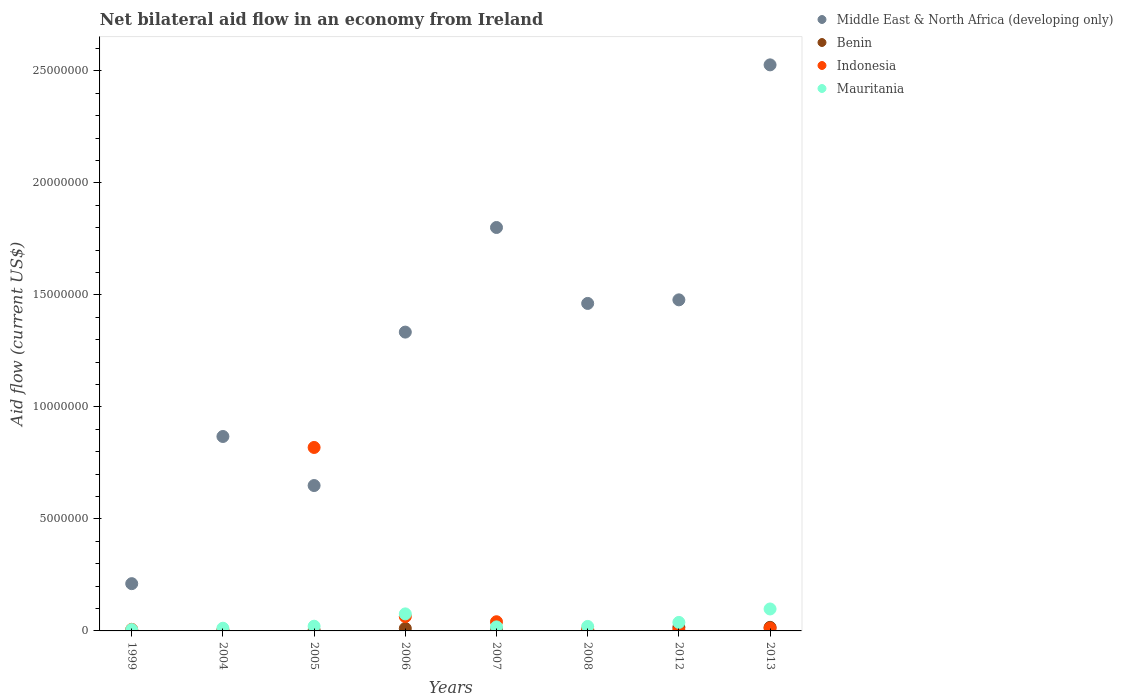What is the net bilateral aid flow in Mauritania in 2005?
Provide a short and direct response. 2.10e+05. Across all years, what is the maximum net bilateral aid flow in Mauritania?
Offer a terse response. 9.80e+05. Across all years, what is the minimum net bilateral aid flow in Mauritania?
Provide a succinct answer. 6.00e+04. In which year was the net bilateral aid flow in Benin maximum?
Your response must be concise. 2012. What is the total net bilateral aid flow in Middle East & North Africa (developing only) in the graph?
Offer a very short reply. 1.03e+08. What is the difference between the net bilateral aid flow in Indonesia in 2006 and that in 2008?
Provide a short and direct response. 5.60e+05. What is the average net bilateral aid flow in Mauritania per year?
Make the answer very short. 3.61e+05. In the year 1999, what is the difference between the net bilateral aid flow in Benin and net bilateral aid flow in Indonesia?
Provide a short and direct response. -5.00e+04. In how many years, is the net bilateral aid flow in Benin greater than 24000000 US$?
Your answer should be very brief. 0. Is the net bilateral aid flow in Indonesia in 2005 less than that in 2012?
Your response must be concise. No. What is the difference between the highest and the second highest net bilateral aid flow in Indonesia?
Provide a succinct answer. 7.55e+06. What is the difference between the highest and the lowest net bilateral aid flow in Mauritania?
Offer a very short reply. 9.20e+05. In how many years, is the net bilateral aid flow in Middle East & North Africa (developing only) greater than the average net bilateral aid flow in Middle East & North Africa (developing only) taken over all years?
Provide a short and direct response. 5. Is it the case that in every year, the sum of the net bilateral aid flow in Benin and net bilateral aid flow in Mauritania  is greater than the sum of net bilateral aid flow in Middle East & North Africa (developing only) and net bilateral aid flow in Indonesia?
Make the answer very short. No. Is the net bilateral aid flow in Middle East & North Africa (developing only) strictly greater than the net bilateral aid flow in Mauritania over the years?
Offer a very short reply. Yes. Is the net bilateral aid flow in Benin strictly less than the net bilateral aid flow in Indonesia over the years?
Ensure brevity in your answer.  No. How many dotlines are there?
Make the answer very short. 4. Are the values on the major ticks of Y-axis written in scientific E-notation?
Your answer should be compact. No. Does the graph contain grids?
Your answer should be very brief. No. How are the legend labels stacked?
Keep it short and to the point. Vertical. What is the title of the graph?
Your answer should be very brief. Net bilateral aid flow in an economy from Ireland. Does "Nicaragua" appear as one of the legend labels in the graph?
Provide a succinct answer. No. What is the label or title of the X-axis?
Offer a very short reply. Years. What is the Aid flow (current US$) of Middle East & North Africa (developing only) in 1999?
Provide a short and direct response. 2.11e+06. What is the Aid flow (current US$) of Middle East & North Africa (developing only) in 2004?
Give a very brief answer. 8.68e+06. What is the Aid flow (current US$) of Benin in 2004?
Your response must be concise. 10000. What is the Aid flow (current US$) in Indonesia in 2004?
Your response must be concise. 3.00e+04. What is the Aid flow (current US$) of Middle East & North Africa (developing only) in 2005?
Keep it short and to the point. 6.49e+06. What is the Aid flow (current US$) of Indonesia in 2005?
Give a very brief answer. 8.19e+06. What is the Aid flow (current US$) in Middle East & North Africa (developing only) in 2006?
Give a very brief answer. 1.33e+07. What is the Aid flow (current US$) in Benin in 2006?
Your answer should be very brief. 1.10e+05. What is the Aid flow (current US$) in Indonesia in 2006?
Offer a very short reply. 6.40e+05. What is the Aid flow (current US$) in Mauritania in 2006?
Your response must be concise. 7.60e+05. What is the Aid flow (current US$) of Middle East & North Africa (developing only) in 2007?
Ensure brevity in your answer.  1.80e+07. What is the Aid flow (current US$) of Middle East & North Africa (developing only) in 2008?
Offer a very short reply. 1.46e+07. What is the Aid flow (current US$) of Benin in 2008?
Provide a succinct answer. 6.00e+04. What is the Aid flow (current US$) of Mauritania in 2008?
Ensure brevity in your answer.  2.00e+05. What is the Aid flow (current US$) in Middle East & North Africa (developing only) in 2012?
Your answer should be very brief. 1.48e+07. What is the Aid flow (current US$) of Benin in 2012?
Your answer should be compact. 1.60e+05. What is the Aid flow (current US$) in Mauritania in 2012?
Make the answer very short. 3.80e+05. What is the Aid flow (current US$) in Middle East & North Africa (developing only) in 2013?
Your answer should be compact. 2.53e+07. What is the Aid flow (current US$) of Benin in 2013?
Make the answer very short. 1.60e+05. What is the Aid flow (current US$) in Mauritania in 2013?
Provide a short and direct response. 9.80e+05. Across all years, what is the maximum Aid flow (current US$) in Middle East & North Africa (developing only)?
Your answer should be compact. 2.53e+07. Across all years, what is the maximum Aid flow (current US$) of Benin?
Make the answer very short. 1.60e+05. Across all years, what is the maximum Aid flow (current US$) in Indonesia?
Provide a succinct answer. 8.19e+06. Across all years, what is the maximum Aid flow (current US$) in Mauritania?
Offer a terse response. 9.80e+05. Across all years, what is the minimum Aid flow (current US$) of Middle East & North Africa (developing only)?
Make the answer very short. 2.11e+06. Across all years, what is the minimum Aid flow (current US$) in Mauritania?
Keep it short and to the point. 6.00e+04. What is the total Aid flow (current US$) of Middle East & North Africa (developing only) in the graph?
Offer a terse response. 1.03e+08. What is the total Aid flow (current US$) in Benin in the graph?
Keep it short and to the point. 6.40e+05. What is the total Aid flow (current US$) in Indonesia in the graph?
Your response must be concise. 9.57e+06. What is the total Aid flow (current US$) of Mauritania in the graph?
Ensure brevity in your answer.  2.89e+06. What is the difference between the Aid flow (current US$) in Middle East & North Africa (developing only) in 1999 and that in 2004?
Make the answer very short. -6.57e+06. What is the difference between the Aid flow (current US$) of Middle East & North Africa (developing only) in 1999 and that in 2005?
Give a very brief answer. -4.38e+06. What is the difference between the Aid flow (current US$) of Indonesia in 1999 and that in 2005?
Your answer should be compact. -8.12e+06. What is the difference between the Aid flow (current US$) of Mauritania in 1999 and that in 2005?
Your answer should be compact. -1.50e+05. What is the difference between the Aid flow (current US$) of Middle East & North Africa (developing only) in 1999 and that in 2006?
Make the answer very short. -1.12e+07. What is the difference between the Aid flow (current US$) of Indonesia in 1999 and that in 2006?
Ensure brevity in your answer.  -5.70e+05. What is the difference between the Aid flow (current US$) of Mauritania in 1999 and that in 2006?
Your answer should be compact. -7.00e+05. What is the difference between the Aid flow (current US$) in Middle East & North Africa (developing only) in 1999 and that in 2007?
Your answer should be very brief. -1.59e+07. What is the difference between the Aid flow (current US$) of Middle East & North Africa (developing only) in 1999 and that in 2008?
Your response must be concise. -1.25e+07. What is the difference between the Aid flow (current US$) in Benin in 1999 and that in 2008?
Provide a short and direct response. -4.00e+04. What is the difference between the Aid flow (current US$) of Indonesia in 1999 and that in 2008?
Provide a short and direct response. -10000. What is the difference between the Aid flow (current US$) of Mauritania in 1999 and that in 2008?
Provide a short and direct response. -1.40e+05. What is the difference between the Aid flow (current US$) of Middle East & North Africa (developing only) in 1999 and that in 2012?
Your response must be concise. -1.27e+07. What is the difference between the Aid flow (current US$) of Indonesia in 1999 and that in 2012?
Ensure brevity in your answer.  4.00e+04. What is the difference between the Aid flow (current US$) in Mauritania in 1999 and that in 2012?
Give a very brief answer. -3.20e+05. What is the difference between the Aid flow (current US$) of Middle East & North Africa (developing only) in 1999 and that in 2013?
Provide a short and direct response. -2.32e+07. What is the difference between the Aid flow (current US$) in Indonesia in 1999 and that in 2013?
Provide a succinct answer. -5.00e+04. What is the difference between the Aid flow (current US$) in Mauritania in 1999 and that in 2013?
Provide a succinct answer. -9.20e+05. What is the difference between the Aid flow (current US$) of Middle East & North Africa (developing only) in 2004 and that in 2005?
Your answer should be compact. 2.19e+06. What is the difference between the Aid flow (current US$) of Indonesia in 2004 and that in 2005?
Your response must be concise. -8.16e+06. What is the difference between the Aid flow (current US$) of Mauritania in 2004 and that in 2005?
Offer a terse response. -9.00e+04. What is the difference between the Aid flow (current US$) in Middle East & North Africa (developing only) in 2004 and that in 2006?
Your answer should be very brief. -4.66e+06. What is the difference between the Aid flow (current US$) of Indonesia in 2004 and that in 2006?
Provide a succinct answer. -6.10e+05. What is the difference between the Aid flow (current US$) in Mauritania in 2004 and that in 2006?
Your answer should be very brief. -6.40e+05. What is the difference between the Aid flow (current US$) in Middle East & North Africa (developing only) in 2004 and that in 2007?
Offer a very short reply. -9.33e+06. What is the difference between the Aid flow (current US$) in Indonesia in 2004 and that in 2007?
Offer a very short reply. -3.80e+05. What is the difference between the Aid flow (current US$) in Mauritania in 2004 and that in 2007?
Ensure brevity in your answer.  -6.00e+04. What is the difference between the Aid flow (current US$) in Middle East & North Africa (developing only) in 2004 and that in 2008?
Provide a short and direct response. -5.94e+06. What is the difference between the Aid flow (current US$) of Middle East & North Africa (developing only) in 2004 and that in 2012?
Provide a short and direct response. -6.10e+06. What is the difference between the Aid flow (current US$) in Mauritania in 2004 and that in 2012?
Make the answer very short. -2.60e+05. What is the difference between the Aid flow (current US$) of Middle East & North Africa (developing only) in 2004 and that in 2013?
Ensure brevity in your answer.  -1.66e+07. What is the difference between the Aid flow (current US$) of Indonesia in 2004 and that in 2013?
Keep it short and to the point. -9.00e+04. What is the difference between the Aid flow (current US$) of Mauritania in 2004 and that in 2013?
Offer a terse response. -8.60e+05. What is the difference between the Aid flow (current US$) in Middle East & North Africa (developing only) in 2005 and that in 2006?
Ensure brevity in your answer.  -6.85e+06. What is the difference between the Aid flow (current US$) in Benin in 2005 and that in 2006?
Your answer should be very brief. -8.00e+04. What is the difference between the Aid flow (current US$) of Indonesia in 2005 and that in 2006?
Your answer should be very brief. 7.55e+06. What is the difference between the Aid flow (current US$) in Mauritania in 2005 and that in 2006?
Your answer should be very brief. -5.50e+05. What is the difference between the Aid flow (current US$) of Middle East & North Africa (developing only) in 2005 and that in 2007?
Give a very brief answer. -1.15e+07. What is the difference between the Aid flow (current US$) of Benin in 2005 and that in 2007?
Give a very brief answer. -6.00e+04. What is the difference between the Aid flow (current US$) in Indonesia in 2005 and that in 2007?
Keep it short and to the point. 7.78e+06. What is the difference between the Aid flow (current US$) of Middle East & North Africa (developing only) in 2005 and that in 2008?
Offer a terse response. -8.13e+06. What is the difference between the Aid flow (current US$) in Indonesia in 2005 and that in 2008?
Give a very brief answer. 8.11e+06. What is the difference between the Aid flow (current US$) in Mauritania in 2005 and that in 2008?
Keep it short and to the point. 10000. What is the difference between the Aid flow (current US$) of Middle East & North Africa (developing only) in 2005 and that in 2012?
Give a very brief answer. -8.29e+06. What is the difference between the Aid flow (current US$) in Indonesia in 2005 and that in 2012?
Keep it short and to the point. 8.16e+06. What is the difference between the Aid flow (current US$) of Mauritania in 2005 and that in 2012?
Your answer should be compact. -1.70e+05. What is the difference between the Aid flow (current US$) in Middle East & North Africa (developing only) in 2005 and that in 2013?
Keep it short and to the point. -1.88e+07. What is the difference between the Aid flow (current US$) of Benin in 2005 and that in 2013?
Keep it short and to the point. -1.30e+05. What is the difference between the Aid flow (current US$) of Indonesia in 2005 and that in 2013?
Offer a very short reply. 8.07e+06. What is the difference between the Aid flow (current US$) of Mauritania in 2005 and that in 2013?
Provide a short and direct response. -7.70e+05. What is the difference between the Aid flow (current US$) in Middle East & North Africa (developing only) in 2006 and that in 2007?
Keep it short and to the point. -4.67e+06. What is the difference between the Aid flow (current US$) in Mauritania in 2006 and that in 2007?
Your response must be concise. 5.80e+05. What is the difference between the Aid flow (current US$) of Middle East & North Africa (developing only) in 2006 and that in 2008?
Ensure brevity in your answer.  -1.28e+06. What is the difference between the Aid flow (current US$) in Indonesia in 2006 and that in 2008?
Provide a succinct answer. 5.60e+05. What is the difference between the Aid flow (current US$) in Mauritania in 2006 and that in 2008?
Provide a succinct answer. 5.60e+05. What is the difference between the Aid flow (current US$) of Middle East & North Africa (developing only) in 2006 and that in 2012?
Give a very brief answer. -1.44e+06. What is the difference between the Aid flow (current US$) in Indonesia in 2006 and that in 2012?
Offer a terse response. 6.10e+05. What is the difference between the Aid flow (current US$) of Mauritania in 2006 and that in 2012?
Give a very brief answer. 3.80e+05. What is the difference between the Aid flow (current US$) in Middle East & North Africa (developing only) in 2006 and that in 2013?
Offer a very short reply. -1.19e+07. What is the difference between the Aid flow (current US$) in Benin in 2006 and that in 2013?
Offer a very short reply. -5.00e+04. What is the difference between the Aid flow (current US$) in Indonesia in 2006 and that in 2013?
Your answer should be compact. 5.20e+05. What is the difference between the Aid flow (current US$) in Mauritania in 2006 and that in 2013?
Offer a very short reply. -2.20e+05. What is the difference between the Aid flow (current US$) of Middle East & North Africa (developing only) in 2007 and that in 2008?
Your answer should be very brief. 3.39e+06. What is the difference between the Aid flow (current US$) in Benin in 2007 and that in 2008?
Make the answer very short. 3.00e+04. What is the difference between the Aid flow (current US$) in Indonesia in 2007 and that in 2008?
Your answer should be compact. 3.30e+05. What is the difference between the Aid flow (current US$) in Middle East & North Africa (developing only) in 2007 and that in 2012?
Your answer should be compact. 3.23e+06. What is the difference between the Aid flow (current US$) of Indonesia in 2007 and that in 2012?
Give a very brief answer. 3.80e+05. What is the difference between the Aid flow (current US$) in Middle East & North Africa (developing only) in 2007 and that in 2013?
Give a very brief answer. -7.26e+06. What is the difference between the Aid flow (current US$) of Mauritania in 2007 and that in 2013?
Ensure brevity in your answer.  -8.00e+05. What is the difference between the Aid flow (current US$) of Middle East & North Africa (developing only) in 2008 and that in 2012?
Offer a very short reply. -1.60e+05. What is the difference between the Aid flow (current US$) in Benin in 2008 and that in 2012?
Offer a terse response. -1.00e+05. What is the difference between the Aid flow (current US$) of Indonesia in 2008 and that in 2012?
Ensure brevity in your answer.  5.00e+04. What is the difference between the Aid flow (current US$) of Mauritania in 2008 and that in 2012?
Make the answer very short. -1.80e+05. What is the difference between the Aid flow (current US$) in Middle East & North Africa (developing only) in 2008 and that in 2013?
Offer a terse response. -1.06e+07. What is the difference between the Aid flow (current US$) of Benin in 2008 and that in 2013?
Give a very brief answer. -1.00e+05. What is the difference between the Aid flow (current US$) of Indonesia in 2008 and that in 2013?
Provide a short and direct response. -4.00e+04. What is the difference between the Aid flow (current US$) of Mauritania in 2008 and that in 2013?
Your answer should be very brief. -7.80e+05. What is the difference between the Aid flow (current US$) in Middle East & North Africa (developing only) in 2012 and that in 2013?
Offer a very short reply. -1.05e+07. What is the difference between the Aid flow (current US$) in Mauritania in 2012 and that in 2013?
Your answer should be very brief. -6.00e+05. What is the difference between the Aid flow (current US$) in Middle East & North Africa (developing only) in 1999 and the Aid flow (current US$) in Benin in 2004?
Your answer should be very brief. 2.10e+06. What is the difference between the Aid flow (current US$) of Middle East & North Africa (developing only) in 1999 and the Aid flow (current US$) of Indonesia in 2004?
Provide a short and direct response. 2.08e+06. What is the difference between the Aid flow (current US$) of Middle East & North Africa (developing only) in 1999 and the Aid flow (current US$) of Mauritania in 2004?
Provide a succinct answer. 1.99e+06. What is the difference between the Aid flow (current US$) of Indonesia in 1999 and the Aid flow (current US$) of Mauritania in 2004?
Your answer should be very brief. -5.00e+04. What is the difference between the Aid flow (current US$) of Middle East & North Africa (developing only) in 1999 and the Aid flow (current US$) of Benin in 2005?
Give a very brief answer. 2.08e+06. What is the difference between the Aid flow (current US$) in Middle East & North Africa (developing only) in 1999 and the Aid flow (current US$) in Indonesia in 2005?
Your answer should be compact. -6.08e+06. What is the difference between the Aid flow (current US$) of Middle East & North Africa (developing only) in 1999 and the Aid flow (current US$) of Mauritania in 2005?
Provide a succinct answer. 1.90e+06. What is the difference between the Aid flow (current US$) in Benin in 1999 and the Aid flow (current US$) in Indonesia in 2005?
Your response must be concise. -8.17e+06. What is the difference between the Aid flow (current US$) in Indonesia in 1999 and the Aid flow (current US$) in Mauritania in 2005?
Ensure brevity in your answer.  -1.40e+05. What is the difference between the Aid flow (current US$) of Middle East & North Africa (developing only) in 1999 and the Aid flow (current US$) of Indonesia in 2006?
Provide a short and direct response. 1.47e+06. What is the difference between the Aid flow (current US$) of Middle East & North Africa (developing only) in 1999 and the Aid flow (current US$) of Mauritania in 2006?
Give a very brief answer. 1.35e+06. What is the difference between the Aid flow (current US$) in Benin in 1999 and the Aid flow (current US$) in Indonesia in 2006?
Offer a very short reply. -6.20e+05. What is the difference between the Aid flow (current US$) of Benin in 1999 and the Aid flow (current US$) of Mauritania in 2006?
Your answer should be compact. -7.40e+05. What is the difference between the Aid flow (current US$) in Indonesia in 1999 and the Aid flow (current US$) in Mauritania in 2006?
Offer a terse response. -6.90e+05. What is the difference between the Aid flow (current US$) in Middle East & North Africa (developing only) in 1999 and the Aid flow (current US$) in Benin in 2007?
Keep it short and to the point. 2.02e+06. What is the difference between the Aid flow (current US$) in Middle East & North Africa (developing only) in 1999 and the Aid flow (current US$) in Indonesia in 2007?
Your answer should be compact. 1.70e+06. What is the difference between the Aid flow (current US$) of Middle East & North Africa (developing only) in 1999 and the Aid flow (current US$) of Mauritania in 2007?
Make the answer very short. 1.93e+06. What is the difference between the Aid flow (current US$) of Benin in 1999 and the Aid flow (current US$) of Indonesia in 2007?
Give a very brief answer. -3.90e+05. What is the difference between the Aid flow (current US$) in Benin in 1999 and the Aid flow (current US$) in Mauritania in 2007?
Provide a succinct answer. -1.60e+05. What is the difference between the Aid flow (current US$) of Indonesia in 1999 and the Aid flow (current US$) of Mauritania in 2007?
Ensure brevity in your answer.  -1.10e+05. What is the difference between the Aid flow (current US$) in Middle East & North Africa (developing only) in 1999 and the Aid flow (current US$) in Benin in 2008?
Provide a short and direct response. 2.05e+06. What is the difference between the Aid flow (current US$) in Middle East & North Africa (developing only) in 1999 and the Aid flow (current US$) in Indonesia in 2008?
Make the answer very short. 2.03e+06. What is the difference between the Aid flow (current US$) of Middle East & North Africa (developing only) in 1999 and the Aid flow (current US$) of Mauritania in 2008?
Your answer should be compact. 1.91e+06. What is the difference between the Aid flow (current US$) of Benin in 1999 and the Aid flow (current US$) of Indonesia in 2008?
Your response must be concise. -6.00e+04. What is the difference between the Aid flow (current US$) in Indonesia in 1999 and the Aid flow (current US$) in Mauritania in 2008?
Your response must be concise. -1.30e+05. What is the difference between the Aid flow (current US$) of Middle East & North Africa (developing only) in 1999 and the Aid flow (current US$) of Benin in 2012?
Your answer should be very brief. 1.95e+06. What is the difference between the Aid flow (current US$) of Middle East & North Africa (developing only) in 1999 and the Aid flow (current US$) of Indonesia in 2012?
Ensure brevity in your answer.  2.08e+06. What is the difference between the Aid flow (current US$) in Middle East & North Africa (developing only) in 1999 and the Aid flow (current US$) in Mauritania in 2012?
Keep it short and to the point. 1.73e+06. What is the difference between the Aid flow (current US$) of Benin in 1999 and the Aid flow (current US$) of Mauritania in 2012?
Provide a succinct answer. -3.60e+05. What is the difference between the Aid flow (current US$) of Indonesia in 1999 and the Aid flow (current US$) of Mauritania in 2012?
Provide a succinct answer. -3.10e+05. What is the difference between the Aid flow (current US$) in Middle East & North Africa (developing only) in 1999 and the Aid flow (current US$) in Benin in 2013?
Make the answer very short. 1.95e+06. What is the difference between the Aid flow (current US$) of Middle East & North Africa (developing only) in 1999 and the Aid flow (current US$) of Indonesia in 2013?
Your response must be concise. 1.99e+06. What is the difference between the Aid flow (current US$) in Middle East & North Africa (developing only) in 1999 and the Aid flow (current US$) in Mauritania in 2013?
Your answer should be compact. 1.13e+06. What is the difference between the Aid flow (current US$) in Benin in 1999 and the Aid flow (current US$) in Mauritania in 2013?
Your response must be concise. -9.60e+05. What is the difference between the Aid flow (current US$) in Indonesia in 1999 and the Aid flow (current US$) in Mauritania in 2013?
Give a very brief answer. -9.10e+05. What is the difference between the Aid flow (current US$) in Middle East & North Africa (developing only) in 2004 and the Aid flow (current US$) in Benin in 2005?
Make the answer very short. 8.65e+06. What is the difference between the Aid flow (current US$) in Middle East & North Africa (developing only) in 2004 and the Aid flow (current US$) in Mauritania in 2005?
Your answer should be compact. 8.47e+06. What is the difference between the Aid flow (current US$) in Benin in 2004 and the Aid flow (current US$) in Indonesia in 2005?
Ensure brevity in your answer.  -8.18e+06. What is the difference between the Aid flow (current US$) of Benin in 2004 and the Aid flow (current US$) of Mauritania in 2005?
Your answer should be compact. -2.00e+05. What is the difference between the Aid flow (current US$) of Indonesia in 2004 and the Aid flow (current US$) of Mauritania in 2005?
Offer a very short reply. -1.80e+05. What is the difference between the Aid flow (current US$) in Middle East & North Africa (developing only) in 2004 and the Aid flow (current US$) in Benin in 2006?
Provide a short and direct response. 8.57e+06. What is the difference between the Aid flow (current US$) of Middle East & North Africa (developing only) in 2004 and the Aid flow (current US$) of Indonesia in 2006?
Ensure brevity in your answer.  8.04e+06. What is the difference between the Aid flow (current US$) in Middle East & North Africa (developing only) in 2004 and the Aid flow (current US$) in Mauritania in 2006?
Offer a very short reply. 7.92e+06. What is the difference between the Aid flow (current US$) in Benin in 2004 and the Aid flow (current US$) in Indonesia in 2006?
Offer a very short reply. -6.30e+05. What is the difference between the Aid flow (current US$) of Benin in 2004 and the Aid flow (current US$) of Mauritania in 2006?
Keep it short and to the point. -7.50e+05. What is the difference between the Aid flow (current US$) of Indonesia in 2004 and the Aid flow (current US$) of Mauritania in 2006?
Your response must be concise. -7.30e+05. What is the difference between the Aid flow (current US$) of Middle East & North Africa (developing only) in 2004 and the Aid flow (current US$) of Benin in 2007?
Provide a succinct answer. 8.59e+06. What is the difference between the Aid flow (current US$) in Middle East & North Africa (developing only) in 2004 and the Aid flow (current US$) in Indonesia in 2007?
Your response must be concise. 8.27e+06. What is the difference between the Aid flow (current US$) of Middle East & North Africa (developing only) in 2004 and the Aid flow (current US$) of Mauritania in 2007?
Provide a succinct answer. 8.50e+06. What is the difference between the Aid flow (current US$) of Benin in 2004 and the Aid flow (current US$) of Indonesia in 2007?
Your answer should be compact. -4.00e+05. What is the difference between the Aid flow (current US$) in Benin in 2004 and the Aid flow (current US$) in Mauritania in 2007?
Offer a terse response. -1.70e+05. What is the difference between the Aid flow (current US$) in Indonesia in 2004 and the Aid flow (current US$) in Mauritania in 2007?
Offer a terse response. -1.50e+05. What is the difference between the Aid flow (current US$) in Middle East & North Africa (developing only) in 2004 and the Aid flow (current US$) in Benin in 2008?
Your answer should be compact. 8.62e+06. What is the difference between the Aid flow (current US$) of Middle East & North Africa (developing only) in 2004 and the Aid flow (current US$) of Indonesia in 2008?
Your answer should be very brief. 8.60e+06. What is the difference between the Aid flow (current US$) of Middle East & North Africa (developing only) in 2004 and the Aid flow (current US$) of Mauritania in 2008?
Give a very brief answer. 8.48e+06. What is the difference between the Aid flow (current US$) in Indonesia in 2004 and the Aid flow (current US$) in Mauritania in 2008?
Your answer should be very brief. -1.70e+05. What is the difference between the Aid flow (current US$) of Middle East & North Africa (developing only) in 2004 and the Aid flow (current US$) of Benin in 2012?
Ensure brevity in your answer.  8.52e+06. What is the difference between the Aid flow (current US$) of Middle East & North Africa (developing only) in 2004 and the Aid flow (current US$) of Indonesia in 2012?
Provide a succinct answer. 8.65e+06. What is the difference between the Aid flow (current US$) in Middle East & North Africa (developing only) in 2004 and the Aid flow (current US$) in Mauritania in 2012?
Your answer should be compact. 8.30e+06. What is the difference between the Aid flow (current US$) of Benin in 2004 and the Aid flow (current US$) of Indonesia in 2012?
Provide a short and direct response. -2.00e+04. What is the difference between the Aid flow (current US$) of Benin in 2004 and the Aid flow (current US$) of Mauritania in 2012?
Keep it short and to the point. -3.70e+05. What is the difference between the Aid flow (current US$) of Indonesia in 2004 and the Aid flow (current US$) of Mauritania in 2012?
Your answer should be compact. -3.50e+05. What is the difference between the Aid flow (current US$) in Middle East & North Africa (developing only) in 2004 and the Aid flow (current US$) in Benin in 2013?
Your answer should be compact. 8.52e+06. What is the difference between the Aid flow (current US$) of Middle East & North Africa (developing only) in 2004 and the Aid flow (current US$) of Indonesia in 2013?
Keep it short and to the point. 8.56e+06. What is the difference between the Aid flow (current US$) of Middle East & North Africa (developing only) in 2004 and the Aid flow (current US$) of Mauritania in 2013?
Your response must be concise. 7.70e+06. What is the difference between the Aid flow (current US$) in Benin in 2004 and the Aid flow (current US$) in Mauritania in 2013?
Give a very brief answer. -9.70e+05. What is the difference between the Aid flow (current US$) in Indonesia in 2004 and the Aid flow (current US$) in Mauritania in 2013?
Offer a very short reply. -9.50e+05. What is the difference between the Aid flow (current US$) of Middle East & North Africa (developing only) in 2005 and the Aid flow (current US$) of Benin in 2006?
Provide a short and direct response. 6.38e+06. What is the difference between the Aid flow (current US$) of Middle East & North Africa (developing only) in 2005 and the Aid flow (current US$) of Indonesia in 2006?
Offer a terse response. 5.85e+06. What is the difference between the Aid flow (current US$) of Middle East & North Africa (developing only) in 2005 and the Aid flow (current US$) of Mauritania in 2006?
Give a very brief answer. 5.73e+06. What is the difference between the Aid flow (current US$) of Benin in 2005 and the Aid flow (current US$) of Indonesia in 2006?
Your response must be concise. -6.10e+05. What is the difference between the Aid flow (current US$) in Benin in 2005 and the Aid flow (current US$) in Mauritania in 2006?
Your response must be concise. -7.30e+05. What is the difference between the Aid flow (current US$) of Indonesia in 2005 and the Aid flow (current US$) of Mauritania in 2006?
Your response must be concise. 7.43e+06. What is the difference between the Aid flow (current US$) of Middle East & North Africa (developing only) in 2005 and the Aid flow (current US$) of Benin in 2007?
Make the answer very short. 6.40e+06. What is the difference between the Aid flow (current US$) of Middle East & North Africa (developing only) in 2005 and the Aid flow (current US$) of Indonesia in 2007?
Offer a terse response. 6.08e+06. What is the difference between the Aid flow (current US$) of Middle East & North Africa (developing only) in 2005 and the Aid flow (current US$) of Mauritania in 2007?
Ensure brevity in your answer.  6.31e+06. What is the difference between the Aid flow (current US$) of Benin in 2005 and the Aid flow (current US$) of Indonesia in 2007?
Offer a terse response. -3.80e+05. What is the difference between the Aid flow (current US$) in Benin in 2005 and the Aid flow (current US$) in Mauritania in 2007?
Provide a succinct answer. -1.50e+05. What is the difference between the Aid flow (current US$) of Indonesia in 2005 and the Aid flow (current US$) of Mauritania in 2007?
Provide a short and direct response. 8.01e+06. What is the difference between the Aid flow (current US$) of Middle East & North Africa (developing only) in 2005 and the Aid flow (current US$) of Benin in 2008?
Your answer should be compact. 6.43e+06. What is the difference between the Aid flow (current US$) in Middle East & North Africa (developing only) in 2005 and the Aid flow (current US$) in Indonesia in 2008?
Keep it short and to the point. 6.41e+06. What is the difference between the Aid flow (current US$) of Middle East & North Africa (developing only) in 2005 and the Aid flow (current US$) of Mauritania in 2008?
Ensure brevity in your answer.  6.29e+06. What is the difference between the Aid flow (current US$) in Benin in 2005 and the Aid flow (current US$) in Mauritania in 2008?
Offer a very short reply. -1.70e+05. What is the difference between the Aid flow (current US$) in Indonesia in 2005 and the Aid flow (current US$) in Mauritania in 2008?
Your answer should be compact. 7.99e+06. What is the difference between the Aid flow (current US$) of Middle East & North Africa (developing only) in 2005 and the Aid flow (current US$) of Benin in 2012?
Your answer should be compact. 6.33e+06. What is the difference between the Aid flow (current US$) of Middle East & North Africa (developing only) in 2005 and the Aid flow (current US$) of Indonesia in 2012?
Provide a short and direct response. 6.46e+06. What is the difference between the Aid flow (current US$) of Middle East & North Africa (developing only) in 2005 and the Aid flow (current US$) of Mauritania in 2012?
Keep it short and to the point. 6.11e+06. What is the difference between the Aid flow (current US$) in Benin in 2005 and the Aid flow (current US$) in Indonesia in 2012?
Provide a short and direct response. 0. What is the difference between the Aid flow (current US$) of Benin in 2005 and the Aid flow (current US$) of Mauritania in 2012?
Give a very brief answer. -3.50e+05. What is the difference between the Aid flow (current US$) of Indonesia in 2005 and the Aid flow (current US$) of Mauritania in 2012?
Ensure brevity in your answer.  7.81e+06. What is the difference between the Aid flow (current US$) in Middle East & North Africa (developing only) in 2005 and the Aid flow (current US$) in Benin in 2013?
Give a very brief answer. 6.33e+06. What is the difference between the Aid flow (current US$) in Middle East & North Africa (developing only) in 2005 and the Aid flow (current US$) in Indonesia in 2013?
Your answer should be compact. 6.37e+06. What is the difference between the Aid flow (current US$) of Middle East & North Africa (developing only) in 2005 and the Aid flow (current US$) of Mauritania in 2013?
Provide a short and direct response. 5.51e+06. What is the difference between the Aid flow (current US$) of Benin in 2005 and the Aid flow (current US$) of Mauritania in 2013?
Your response must be concise. -9.50e+05. What is the difference between the Aid flow (current US$) in Indonesia in 2005 and the Aid flow (current US$) in Mauritania in 2013?
Your response must be concise. 7.21e+06. What is the difference between the Aid flow (current US$) in Middle East & North Africa (developing only) in 2006 and the Aid flow (current US$) in Benin in 2007?
Make the answer very short. 1.32e+07. What is the difference between the Aid flow (current US$) in Middle East & North Africa (developing only) in 2006 and the Aid flow (current US$) in Indonesia in 2007?
Keep it short and to the point. 1.29e+07. What is the difference between the Aid flow (current US$) of Middle East & North Africa (developing only) in 2006 and the Aid flow (current US$) of Mauritania in 2007?
Provide a succinct answer. 1.32e+07. What is the difference between the Aid flow (current US$) in Benin in 2006 and the Aid flow (current US$) in Indonesia in 2007?
Your answer should be very brief. -3.00e+05. What is the difference between the Aid flow (current US$) of Benin in 2006 and the Aid flow (current US$) of Mauritania in 2007?
Offer a very short reply. -7.00e+04. What is the difference between the Aid flow (current US$) of Middle East & North Africa (developing only) in 2006 and the Aid flow (current US$) of Benin in 2008?
Provide a short and direct response. 1.33e+07. What is the difference between the Aid flow (current US$) in Middle East & North Africa (developing only) in 2006 and the Aid flow (current US$) in Indonesia in 2008?
Provide a succinct answer. 1.33e+07. What is the difference between the Aid flow (current US$) in Middle East & North Africa (developing only) in 2006 and the Aid flow (current US$) in Mauritania in 2008?
Offer a very short reply. 1.31e+07. What is the difference between the Aid flow (current US$) in Benin in 2006 and the Aid flow (current US$) in Indonesia in 2008?
Offer a very short reply. 3.00e+04. What is the difference between the Aid flow (current US$) in Indonesia in 2006 and the Aid flow (current US$) in Mauritania in 2008?
Provide a succinct answer. 4.40e+05. What is the difference between the Aid flow (current US$) of Middle East & North Africa (developing only) in 2006 and the Aid flow (current US$) of Benin in 2012?
Provide a succinct answer. 1.32e+07. What is the difference between the Aid flow (current US$) in Middle East & North Africa (developing only) in 2006 and the Aid flow (current US$) in Indonesia in 2012?
Provide a succinct answer. 1.33e+07. What is the difference between the Aid flow (current US$) in Middle East & North Africa (developing only) in 2006 and the Aid flow (current US$) in Mauritania in 2012?
Give a very brief answer. 1.30e+07. What is the difference between the Aid flow (current US$) of Middle East & North Africa (developing only) in 2006 and the Aid flow (current US$) of Benin in 2013?
Make the answer very short. 1.32e+07. What is the difference between the Aid flow (current US$) in Middle East & North Africa (developing only) in 2006 and the Aid flow (current US$) in Indonesia in 2013?
Your answer should be compact. 1.32e+07. What is the difference between the Aid flow (current US$) of Middle East & North Africa (developing only) in 2006 and the Aid flow (current US$) of Mauritania in 2013?
Your answer should be very brief. 1.24e+07. What is the difference between the Aid flow (current US$) in Benin in 2006 and the Aid flow (current US$) in Mauritania in 2013?
Your response must be concise. -8.70e+05. What is the difference between the Aid flow (current US$) of Middle East & North Africa (developing only) in 2007 and the Aid flow (current US$) of Benin in 2008?
Offer a terse response. 1.80e+07. What is the difference between the Aid flow (current US$) in Middle East & North Africa (developing only) in 2007 and the Aid flow (current US$) in Indonesia in 2008?
Provide a short and direct response. 1.79e+07. What is the difference between the Aid flow (current US$) of Middle East & North Africa (developing only) in 2007 and the Aid flow (current US$) of Mauritania in 2008?
Provide a succinct answer. 1.78e+07. What is the difference between the Aid flow (current US$) of Benin in 2007 and the Aid flow (current US$) of Indonesia in 2008?
Keep it short and to the point. 10000. What is the difference between the Aid flow (current US$) of Benin in 2007 and the Aid flow (current US$) of Mauritania in 2008?
Give a very brief answer. -1.10e+05. What is the difference between the Aid flow (current US$) of Middle East & North Africa (developing only) in 2007 and the Aid flow (current US$) of Benin in 2012?
Provide a succinct answer. 1.78e+07. What is the difference between the Aid flow (current US$) of Middle East & North Africa (developing only) in 2007 and the Aid flow (current US$) of Indonesia in 2012?
Make the answer very short. 1.80e+07. What is the difference between the Aid flow (current US$) of Middle East & North Africa (developing only) in 2007 and the Aid flow (current US$) of Mauritania in 2012?
Your answer should be compact. 1.76e+07. What is the difference between the Aid flow (current US$) in Benin in 2007 and the Aid flow (current US$) in Indonesia in 2012?
Keep it short and to the point. 6.00e+04. What is the difference between the Aid flow (current US$) of Benin in 2007 and the Aid flow (current US$) of Mauritania in 2012?
Offer a very short reply. -2.90e+05. What is the difference between the Aid flow (current US$) of Middle East & North Africa (developing only) in 2007 and the Aid flow (current US$) of Benin in 2013?
Give a very brief answer. 1.78e+07. What is the difference between the Aid flow (current US$) of Middle East & North Africa (developing only) in 2007 and the Aid flow (current US$) of Indonesia in 2013?
Ensure brevity in your answer.  1.79e+07. What is the difference between the Aid flow (current US$) in Middle East & North Africa (developing only) in 2007 and the Aid flow (current US$) in Mauritania in 2013?
Ensure brevity in your answer.  1.70e+07. What is the difference between the Aid flow (current US$) of Benin in 2007 and the Aid flow (current US$) of Mauritania in 2013?
Make the answer very short. -8.90e+05. What is the difference between the Aid flow (current US$) in Indonesia in 2007 and the Aid flow (current US$) in Mauritania in 2013?
Keep it short and to the point. -5.70e+05. What is the difference between the Aid flow (current US$) in Middle East & North Africa (developing only) in 2008 and the Aid flow (current US$) in Benin in 2012?
Offer a very short reply. 1.45e+07. What is the difference between the Aid flow (current US$) in Middle East & North Africa (developing only) in 2008 and the Aid flow (current US$) in Indonesia in 2012?
Ensure brevity in your answer.  1.46e+07. What is the difference between the Aid flow (current US$) in Middle East & North Africa (developing only) in 2008 and the Aid flow (current US$) in Mauritania in 2012?
Your answer should be very brief. 1.42e+07. What is the difference between the Aid flow (current US$) of Benin in 2008 and the Aid flow (current US$) of Indonesia in 2012?
Make the answer very short. 3.00e+04. What is the difference between the Aid flow (current US$) in Benin in 2008 and the Aid flow (current US$) in Mauritania in 2012?
Make the answer very short. -3.20e+05. What is the difference between the Aid flow (current US$) of Indonesia in 2008 and the Aid flow (current US$) of Mauritania in 2012?
Offer a terse response. -3.00e+05. What is the difference between the Aid flow (current US$) in Middle East & North Africa (developing only) in 2008 and the Aid flow (current US$) in Benin in 2013?
Offer a terse response. 1.45e+07. What is the difference between the Aid flow (current US$) of Middle East & North Africa (developing only) in 2008 and the Aid flow (current US$) of Indonesia in 2013?
Make the answer very short. 1.45e+07. What is the difference between the Aid flow (current US$) of Middle East & North Africa (developing only) in 2008 and the Aid flow (current US$) of Mauritania in 2013?
Provide a succinct answer. 1.36e+07. What is the difference between the Aid flow (current US$) in Benin in 2008 and the Aid flow (current US$) in Mauritania in 2013?
Your response must be concise. -9.20e+05. What is the difference between the Aid flow (current US$) in Indonesia in 2008 and the Aid flow (current US$) in Mauritania in 2013?
Keep it short and to the point. -9.00e+05. What is the difference between the Aid flow (current US$) of Middle East & North Africa (developing only) in 2012 and the Aid flow (current US$) of Benin in 2013?
Your response must be concise. 1.46e+07. What is the difference between the Aid flow (current US$) in Middle East & North Africa (developing only) in 2012 and the Aid flow (current US$) in Indonesia in 2013?
Keep it short and to the point. 1.47e+07. What is the difference between the Aid flow (current US$) of Middle East & North Africa (developing only) in 2012 and the Aid flow (current US$) of Mauritania in 2013?
Offer a very short reply. 1.38e+07. What is the difference between the Aid flow (current US$) in Benin in 2012 and the Aid flow (current US$) in Mauritania in 2013?
Give a very brief answer. -8.20e+05. What is the difference between the Aid flow (current US$) of Indonesia in 2012 and the Aid flow (current US$) of Mauritania in 2013?
Offer a very short reply. -9.50e+05. What is the average Aid flow (current US$) in Middle East & North Africa (developing only) per year?
Your answer should be compact. 1.29e+07. What is the average Aid flow (current US$) in Indonesia per year?
Provide a short and direct response. 1.20e+06. What is the average Aid flow (current US$) of Mauritania per year?
Ensure brevity in your answer.  3.61e+05. In the year 1999, what is the difference between the Aid flow (current US$) in Middle East & North Africa (developing only) and Aid flow (current US$) in Benin?
Offer a terse response. 2.09e+06. In the year 1999, what is the difference between the Aid flow (current US$) of Middle East & North Africa (developing only) and Aid flow (current US$) of Indonesia?
Keep it short and to the point. 2.04e+06. In the year 1999, what is the difference between the Aid flow (current US$) in Middle East & North Africa (developing only) and Aid flow (current US$) in Mauritania?
Your answer should be compact. 2.05e+06. In the year 1999, what is the difference between the Aid flow (current US$) of Benin and Aid flow (current US$) of Mauritania?
Your response must be concise. -4.00e+04. In the year 2004, what is the difference between the Aid flow (current US$) in Middle East & North Africa (developing only) and Aid flow (current US$) in Benin?
Your answer should be very brief. 8.67e+06. In the year 2004, what is the difference between the Aid flow (current US$) in Middle East & North Africa (developing only) and Aid flow (current US$) in Indonesia?
Ensure brevity in your answer.  8.65e+06. In the year 2004, what is the difference between the Aid flow (current US$) of Middle East & North Africa (developing only) and Aid flow (current US$) of Mauritania?
Ensure brevity in your answer.  8.56e+06. In the year 2004, what is the difference between the Aid flow (current US$) in Benin and Aid flow (current US$) in Indonesia?
Provide a succinct answer. -2.00e+04. In the year 2004, what is the difference between the Aid flow (current US$) of Benin and Aid flow (current US$) of Mauritania?
Offer a very short reply. -1.10e+05. In the year 2004, what is the difference between the Aid flow (current US$) in Indonesia and Aid flow (current US$) in Mauritania?
Provide a short and direct response. -9.00e+04. In the year 2005, what is the difference between the Aid flow (current US$) in Middle East & North Africa (developing only) and Aid flow (current US$) in Benin?
Give a very brief answer. 6.46e+06. In the year 2005, what is the difference between the Aid flow (current US$) in Middle East & North Africa (developing only) and Aid flow (current US$) in Indonesia?
Your answer should be very brief. -1.70e+06. In the year 2005, what is the difference between the Aid flow (current US$) of Middle East & North Africa (developing only) and Aid flow (current US$) of Mauritania?
Keep it short and to the point. 6.28e+06. In the year 2005, what is the difference between the Aid flow (current US$) in Benin and Aid flow (current US$) in Indonesia?
Ensure brevity in your answer.  -8.16e+06. In the year 2005, what is the difference between the Aid flow (current US$) in Benin and Aid flow (current US$) in Mauritania?
Your response must be concise. -1.80e+05. In the year 2005, what is the difference between the Aid flow (current US$) in Indonesia and Aid flow (current US$) in Mauritania?
Provide a succinct answer. 7.98e+06. In the year 2006, what is the difference between the Aid flow (current US$) in Middle East & North Africa (developing only) and Aid flow (current US$) in Benin?
Provide a short and direct response. 1.32e+07. In the year 2006, what is the difference between the Aid flow (current US$) of Middle East & North Africa (developing only) and Aid flow (current US$) of Indonesia?
Offer a terse response. 1.27e+07. In the year 2006, what is the difference between the Aid flow (current US$) in Middle East & North Africa (developing only) and Aid flow (current US$) in Mauritania?
Offer a terse response. 1.26e+07. In the year 2006, what is the difference between the Aid flow (current US$) in Benin and Aid flow (current US$) in Indonesia?
Your answer should be compact. -5.30e+05. In the year 2006, what is the difference between the Aid flow (current US$) in Benin and Aid flow (current US$) in Mauritania?
Provide a succinct answer. -6.50e+05. In the year 2007, what is the difference between the Aid flow (current US$) in Middle East & North Africa (developing only) and Aid flow (current US$) in Benin?
Ensure brevity in your answer.  1.79e+07. In the year 2007, what is the difference between the Aid flow (current US$) of Middle East & North Africa (developing only) and Aid flow (current US$) of Indonesia?
Offer a very short reply. 1.76e+07. In the year 2007, what is the difference between the Aid flow (current US$) of Middle East & North Africa (developing only) and Aid flow (current US$) of Mauritania?
Provide a succinct answer. 1.78e+07. In the year 2007, what is the difference between the Aid flow (current US$) of Benin and Aid flow (current US$) of Indonesia?
Offer a very short reply. -3.20e+05. In the year 2007, what is the difference between the Aid flow (current US$) of Indonesia and Aid flow (current US$) of Mauritania?
Offer a very short reply. 2.30e+05. In the year 2008, what is the difference between the Aid flow (current US$) of Middle East & North Africa (developing only) and Aid flow (current US$) of Benin?
Give a very brief answer. 1.46e+07. In the year 2008, what is the difference between the Aid flow (current US$) of Middle East & North Africa (developing only) and Aid flow (current US$) of Indonesia?
Your response must be concise. 1.45e+07. In the year 2008, what is the difference between the Aid flow (current US$) of Middle East & North Africa (developing only) and Aid flow (current US$) of Mauritania?
Your answer should be compact. 1.44e+07. In the year 2008, what is the difference between the Aid flow (current US$) in Benin and Aid flow (current US$) in Mauritania?
Make the answer very short. -1.40e+05. In the year 2012, what is the difference between the Aid flow (current US$) in Middle East & North Africa (developing only) and Aid flow (current US$) in Benin?
Your answer should be compact. 1.46e+07. In the year 2012, what is the difference between the Aid flow (current US$) of Middle East & North Africa (developing only) and Aid flow (current US$) of Indonesia?
Your response must be concise. 1.48e+07. In the year 2012, what is the difference between the Aid flow (current US$) of Middle East & North Africa (developing only) and Aid flow (current US$) of Mauritania?
Give a very brief answer. 1.44e+07. In the year 2012, what is the difference between the Aid flow (current US$) in Benin and Aid flow (current US$) in Mauritania?
Your response must be concise. -2.20e+05. In the year 2012, what is the difference between the Aid flow (current US$) of Indonesia and Aid flow (current US$) of Mauritania?
Offer a very short reply. -3.50e+05. In the year 2013, what is the difference between the Aid flow (current US$) in Middle East & North Africa (developing only) and Aid flow (current US$) in Benin?
Your answer should be compact. 2.51e+07. In the year 2013, what is the difference between the Aid flow (current US$) in Middle East & North Africa (developing only) and Aid flow (current US$) in Indonesia?
Keep it short and to the point. 2.52e+07. In the year 2013, what is the difference between the Aid flow (current US$) in Middle East & North Africa (developing only) and Aid flow (current US$) in Mauritania?
Provide a succinct answer. 2.43e+07. In the year 2013, what is the difference between the Aid flow (current US$) in Benin and Aid flow (current US$) in Indonesia?
Give a very brief answer. 4.00e+04. In the year 2013, what is the difference between the Aid flow (current US$) in Benin and Aid flow (current US$) in Mauritania?
Your response must be concise. -8.20e+05. In the year 2013, what is the difference between the Aid flow (current US$) in Indonesia and Aid flow (current US$) in Mauritania?
Your answer should be compact. -8.60e+05. What is the ratio of the Aid flow (current US$) in Middle East & North Africa (developing only) in 1999 to that in 2004?
Provide a succinct answer. 0.24. What is the ratio of the Aid flow (current US$) of Indonesia in 1999 to that in 2004?
Keep it short and to the point. 2.33. What is the ratio of the Aid flow (current US$) in Middle East & North Africa (developing only) in 1999 to that in 2005?
Offer a terse response. 0.33. What is the ratio of the Aid flow (current US$) in Indonesia in 1999 to that in 2005?
Make the answer very short. 0.01. What is the ratio of the Aid flow (current US$) in Mauritania in 1999 to that in 2005?
Give a very brief answer. 0.29. What is the ratio of the Aid flow (current US$) in Middle East & North Africa (developing only) in 1999 to that in 2006?
Make the answer very short. 0.16. What is the ratio of the Aid flow (current US$) in Benin in 1999 to that in 2006?
Provide a succinct answer. 0.18. What is the ratio of the Aid flow (current US$) in Indonesia in 1999 to that in 2006?
Make the answer very short. 0.11. What is the ratio of the Aid flow (current US$) of Mauritania in 1999 to that in 2006?
Ensure brevity in your answer.  0.08. What is the ratio of the Aid flow (current US$) of Middle East & North Africa (developing only) in 1999 to that in 2007?
Your answer should be compact. 0.12. What is the ratio of the Aid flow (current US$) of Benin in 1999 to that in 2007?
Keep it short and to the point. 0.22. What is the ratio of the Aid flow (current US$) of Indonesia in 1999 to that in 2007?
Offer a terse response. 0.17. What is the ratio of the Aid flow (current US$) of Middle East & North Africa (developing only) in 1999 to that in 2008?
Keep it short and to the point. 0.14. What is the ratio of the Aid flow (current US$) in Mauritania in 1999 to that in 2008?
Offer a very short reply. 0.3. What is the ratio of the Aid flow (current US$) of Middle East & North Africa (developing only) in 1999 to that in 2012?
Ensure brevity in your answer.  0.14. What is the ratio of the Aid flow (current US$) in Benin in 1999 to that in 2012?
Your response must be concise. 0.12. What is the ratio of the Aid flow (current US$) in Indonesia in 1999 to that in 2012?
Offer a very short reply. 2.33. What is the ratio of the Aid flow (current US$) in Mauritania in 1999 to that in 2012?
Provide a succinct answer. 0.16. What is the ratio of the Aid flow (current US$) in Middle East & North Africa (developing only) in 1999 to that in 2013?
Keep it short and to the point. 0.08. What is the ratio of the Aid flow (current US$) in Indonesia in 1999 to that in 2013?
Your answer should be very brief. 0.58. What is the ratio of the Aid flow (current US$) in Mauritania in 1999 to that in 2013?
Keep it short and to the point. 0.06. What is the ratio of the Aid flow (current US$) in Middle East & North Africa (developing only) in 2004 to that in 2005?
Offer a terse response. 1.34. What is the ratio of the Aid flow (current US$) in Benin in 2004 to that in 2005?
Ensure brevity in your answer.  0.33. What is the ratio of the Aid flow (current US$) in Indonesia in 2004 to that in 2005?
Keep it short and to the point. 0. What is the ratio of the Aid flow (current US$) in Mauritania in 2004 to that in 2005?
Give a very brief answer. 0.57. What is the ratio of the Aid flow (current US$) of Middle East & North Africa (developing only) in 2004 to that in 2006?
Provide a succinct answer. 0.65. What is the ratio of the Aid flow (current US$) of Benin in 2004 to that in 2006?
Your answer should be compact. 0.09. What is the ratio of the Aid flow (current US$) of Indonesia in 2004 to that in 2006?
Provide a succinct answer. 0.05. What is the ratio of the Aid flow (current US$) of Mauritania in 2004 to that in 2006?
Give a very brief answer. 0.16. What is the ratio of the Aid flow (current US$) of Middle East & North Africa (developing only) in 2004 to that in 2007?
Ensure brevity in your answer.  0.48. What is the ratio of the Aid flow (current US$) in Benin in 2004 to that in 2007?
Provide a succinct answer. 0.11. What is the ratio of the Aid flow (current US$) in Indonesia in 2004 to that in 2007?
Keep it short and to the point. 0.07. What is the ratio of the Aid flow (current US$) in Middle East & North Africa (developing only) in 2004 to that in 2008?
Your answer should be very brief. 0.59. What is the ratio of the Aid flow (current US$) of Benin in 2004 to that in 2008?
Your response must be concise. 0.17. What is the ratio of the Aid flow (current US$) of Indonesia in 2004 to that in 2008?
Make the answer very short. 0.38. What is the ratio of the Aid flow (current US$) of Mauritania in 2004 to that in 2008?
Your answer should be very brief. 0.6. What is the ratio of the Aid flow (current US$) of Middle East & North Africa (developing only) in 2004 to that in 2012?
Your answer should be compact. 0.59. What is the ratio of the Aid flow (current US$) in Benin in 2004 to that in 2012?
Give a very brief answer. 0.06. What is the ratio of the Aid flow (current US$) of Mauritania in 2004 to that in 2012?
Your answer should be very brief. 0.32. What is the ratio of the Aid flow (current US$) in Middle East & North Africa (developing only) in 2004 to that in 2013?
Provide a short and direct response. 0.34. What is the ratio of the Aid flow (current US$) in Benin in 2004 to that in 2013?
Your answer should be compact. 0.06. What is the ratio of the Aid flow (current US$) of Mauritania in 2004 to that in 2013?
Keep it short and to the point. 0.12. What is the ratio of the Aid flow (current US$) in Middle East & North Africa (developing only) in 2005 to that in 2006?
Your answer should be very brief. 0.49. What is the ratio of the Aid flow (current US$) of Benin in 2005 to that in 2006?
Keep it short and to the point. 0.27. What is the ratio of the Aid flow (current US$) in Indonesia in 2005 to that in 2006?
Provide a short and direct response. 12.8. What is the ratio of the Aid flow (current US$) of Mauritania in 2005 to that in 2006?
Give a very brief answer. 0.28. What is the ratio of the Aid flow (current US$) in Middle East & North Africa (developing only) in 2005 to that in 2007?
Make the answer very short. 0.36. What is the ratio of the Aid flow (current US$) of Benin in 2005 to that in 2007?
Offer a terse response. 0.33. What is the ratio of the Aid flow (current US$) in Indonesia in 2005 to that in 2007?
Provide a succinct answer. 19.98. What is the ratio of the Aid flow (current US$) of Middle East & North Africa (developing only) in 2005 to that in 2008?
Make the answer very short. 0.44. What is the ratio of the Aid flow (current US$) of Indonesia in 2005 to that in 2008?
Make the answer very short. 102.38. What is the ratio of the Aid flow (current US$) in Mauritania in 2005 to that in 2008?
Offer a very short reply. 1.05. What is the ratio of the Aid flow (current US$) of Middle East & North Africa (developing only) in 2005 to that in 2012?
Offer a very short reply. 0.44. What is the ratio of the Aid flow (current US$) of Benin in 2005 to that in 2012?
Provide a succinct answer. 0.19. What is the ratio of the Aid flow (current US$) in Indonesia in 2005 to that in 2012?
Keep it short and to the point. 273. What is the ratio of the Aid flow (current US$) of Mauritania in 2005 to that in 2012?
Make the answer very short. 0.55. What is the ratio of the Aid flow (current US$) in Middle East & North Africa (developing only) in 2005 to that in 2013?
Give a very brief answer. 0.26. What is the ratio of the Aid flow (current US$) of Benin in 2005 to that in 2013?
Provide a short and direct response. 0.19. What is the ratio of the Aid flow (current US$) in Indonesia in 2005 to that in 2013?
Your answer should be very brief. 68.25. What is the ratio of the Aid flow (current US$) in Mauritania in 2005 to that in 2013?
Offer a terse response. 0.21. What is the ratio of the Aid flow (current US$) of Middle East & North Africa (developing only) in 2006 to that in 2007?
Offer a terse response. 0.74. What is the ratio of the Aid flow (current US$) of Benin in 2006 to that in 2007?
Give a very brief answer. 1.22. What is the ratio of the Aid flow (current US$) in Indonesia in 2006 to that in 2007?
Your answer should be compact. 1.56. What is the ratio of the Aid flow (current US$) of Mauritania in 2006 to that in 2007?
Your response must be concise. 4.22. What is the ratio of the Aid flow (current US$) of Middle East & North Africa (developing only) in 2006 to that in 2008?
Keep it short and to the point. 0.91. What is the ratio of the Aid flow (current US$) in Benin in 2006 to that in 2008?
Offer a very short reply. 1.83. What is the ratio of the Aid flow (current US$) in Indonesia in 2006 to that in 2008?
Keep it short and to the point. 8. What is the ratio of the Aid flow (current US$) of Middle East & North Africa (developing only) in 2006 to that in 2012?
Provide a short and direct response. 0.9. What is the ratio of the Aid flow (current US$) of Benin in 2006 to that in 2012?
Give a very brief answer. 0.69. What is the ratio of the Aid flow (current US$) in Indonesia in 2006 to that in 2012?
Provide a short and direct response. 21.33. What is the ratio of the Aid flow (current US$) of Middle East & North Africa (developing only) in 2006 to that in 2013?
Your answer should be compact. 0.53. What is the ratio of the Aid flow (current US$) of Benin in 2006 to that in 2013?
Your answer should be very brief. 0.69. What is the ratio of the Aid flow (current US$) of Indonesia in 2006 to that in 2013?
Offer a very short reply. 5.33. What is the ratio of the Aid flow (current US$) in Mauritania in 2006 to that in 2013?
Ensure brevity in your answer.  0.78. What is the ratio of the Aid flow (current US$) of Middle East & North Africa (developing only) in 2007 to that in 2008?
Provide a succinct answer. 1.23. What is the ratio of the Aid flow (current US$) of Indonesia in 2007 to that in 2008?
Your answer should be very brief. 5.12. What is the ratio of the Aid flow (current US$) of Middle East & North Africa (developing only) in 2007 to that in 2012?
Offer a very short reply. 1.22. What is the ratio of the Aid flow (current US$) of Benin in 2007 to that in 2012?
Make the answer very short. 0.56. What is the ratio of the Aid flow (current US$) in Indonesia in 2007 to that in 2012?
Give a very brief answer. 13.67. What is the ratio of the Aid flow (current US$) of Mauritania in 2007 to that in 2012?
Make the answer very short. 0.47. What is the ratio of the Aid flow (current US$) of Middle East & North Africa (developing only) in 2007 to that in 2013?
Your answer should be very brief. 0.71. What is the ratio of the Aid flow (current US$) in Benin in 2007 to that in 2013?
Provide a succinct answer. 0.56. What is the ratio of the Aid flow (current US$) of Indonesia in 2007 to that in 2013?
Offer a terse response. 3.42. What is the ratio of the Aid flow (current US$) of Mauritania in 2007 to that in 2013?
Give a very brief answer. 0.18. What is the ratio of the Aid flow (current US$) in Middle East & North Africa (developing only) in 2008 to that in 2012?
Offer a terse response. 0.99. What is the ratio of the Aid flow (current US$) in Benin in 2008 to that in 2012?
Your answer should be compact. 0.38. What is the ratio of the Aid flow (current US$) in Indonesia in 2008 to that in 2012?
Keep it short and to the point. 2.67. What is the ratio of the Aid flow (current US$) in Mauritania in 2008 to that in 2012?
Keep it short and to the point. 0.53. What is the ratio of the Aid flow (current US$) of Middle East & North Africa (developing only) in 2008 to that in 2013?
Give a very brief answer. 0.58. What is the ratio of the Aid flow (current US$) in Indonesia in 2008 to that in 2013?
Your response must be concise. 0.67. What is the ratio of the Aid flow (current US$) in Mauritania in 2008 to that in 2013?
Make the answer very short. 0.2. What is the ratio of the Aid flow (current US$) in Middle East & North Africa (developing only) in 2012 to that in 2013?
Offer a terse response. 0.58. What is the ratio of the Aid flow (current US$) in Mauritania in 2012 to that in 2013?
Your answer should be very brief. 0.39. What is the difference between the highest and the second highest Aid flow (current US$) of Middle East & North Africa (developing only)?
Provide a short and direct response. 7.26e+06. What is the difference between the highest and the second highest Aid flow (current US$) in Indonesia?
Ensure brevity in your answer.  7.55e+06. What is the difference between the highest and the second highest Aid flow (current US$) of Mauritania?
Keep it short and to the point. 2.20e+05. What is the difference between the highest and the lowest Aid flow (current US$) of Middle East & North Africa (developing only)?
Give a very brief answer. 2.32e+07. What is the difference between the highest and the lowest Aid flow (current US$) of Benin?
Make the answer very short. 1.50e+05. What is the difference between the highest and the lowest Aid flow (current US$) of Indonesia?
Make the answer very short. 8.16e+06. What is the difference between the highest and the lowest Aid flow (current US$) in Mauritania?
Ensure brevity in your answer.  9.20e+05. 